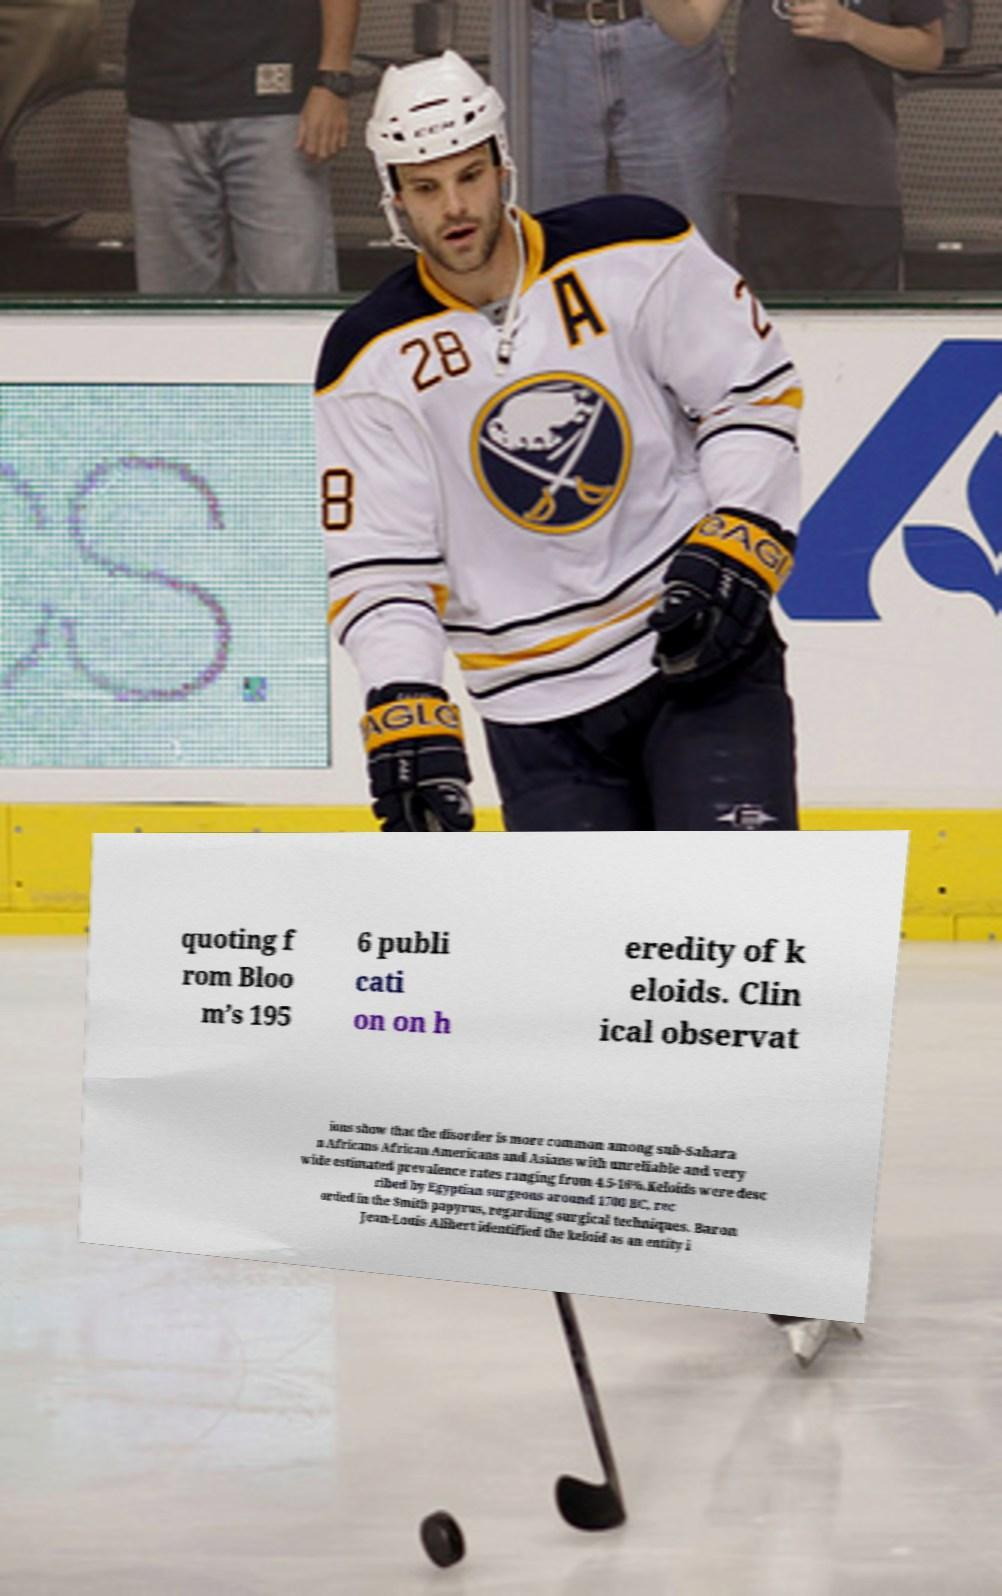Can you read and provide the text displayed in the image?This photo seems to have some interesting text. Can you extract and type it out for me? quoting f rom Bloo m’s 195 6 publi cati on on h eredity of k eloids. Clin ical observat ions show that the disorder is more common among sub-Sahara n Africans African Americans and Asians with unreliable and very wide estimated prevalence rates ranging from 4.5-16%.Keloids were desc ribed by Egyptian surgeons around 1700 BC, rec orded in the Smith papyrus, regarding surgical techniques. Baron Jean-Louis Alibert identified the keloid as an entity i 